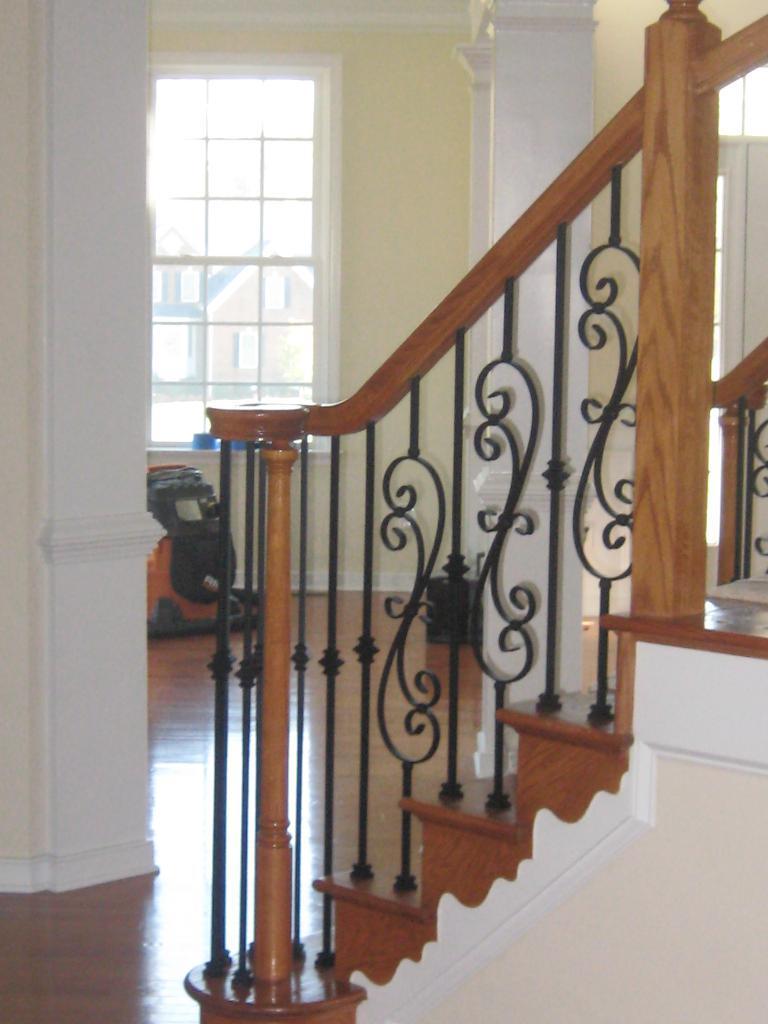In one or two sentences, can you explain what this image depicts? This image is clicked inside the house. In the front, we can see steps along with railing. On the left, there is a pillar. In the background, we can see a window along with a wall. At the bottom, there is an object, it looks like a bag on the floor. 